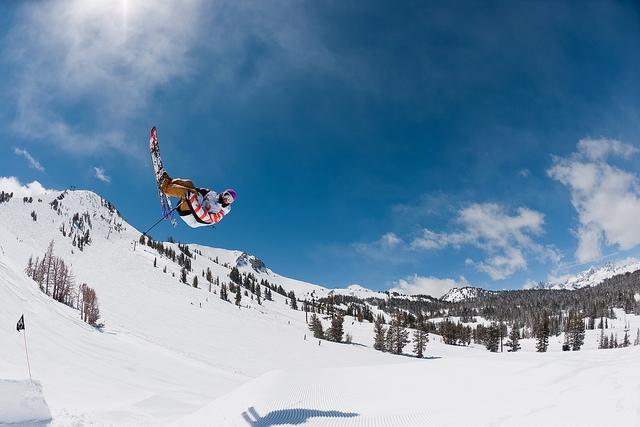What time of day was this picture taken?
Give a very brief answer. Morning. Does he have head protection?
Concise answer only. Yes. What is flying up?
Be succinct. Skier. Is the man skiing or snowboarding?
Write a very short answer. Skiing. Is this a warm summer day?
Quick response, please. No. What sport is this person partaking in?
Write a very short answer. Skiing. 